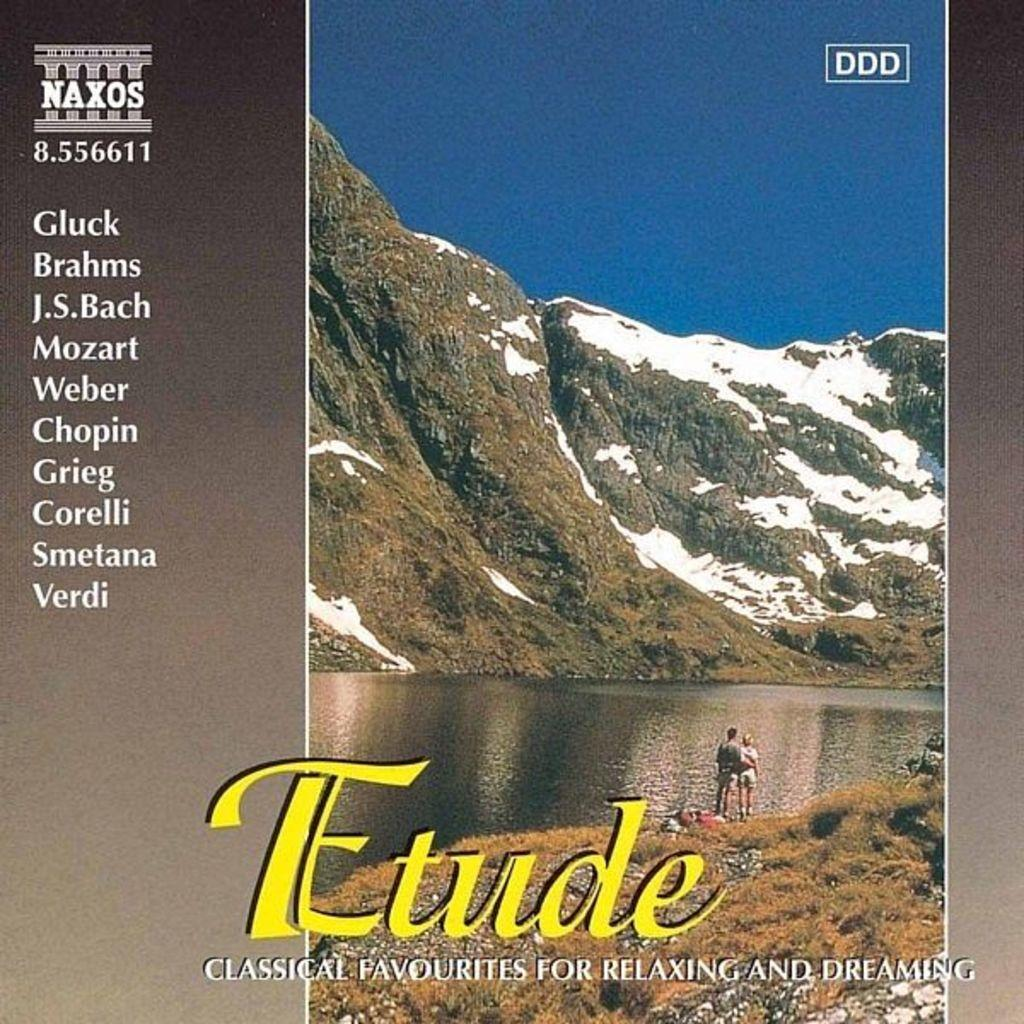<image>
Write a terse but informative summary of the picture. The album Etude where two people are standing in front of a mountain on the cover. 